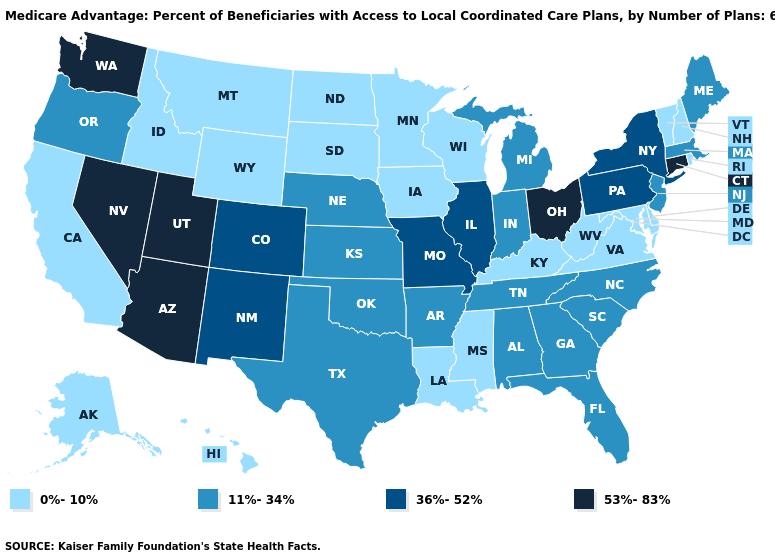Does New Jersey have a lower value than Arizona?
Concise answer only. Yes. What is the value of Texas?
Short answer required. 11%-34%. Does Massachusetts have a higher value than Maine?
Quick response, please. No. Among the states that border Illinois , does Wisconsin have the highest value?
Write a very short answer. No. Which states have the highest value in the USA?
Short answer required. Arizona, Connecticut, Nevada, Ohio, Utah, Washington. Among the states that border Oregon , does Idaho have the lowest value?
Write a very short answer. Yes. Does Georgia have the lowest value in the USA?
Keep it brief. No. Name the states that have a value in the range 36%-52%?
Concise answer only. Colorado, Illinois, Missouri, New Mexico, New York, Pennsylvania. Name the states that have a value in the range 11%-34%?
Quick response, please. Alabama, Arkansas, Florida, Georgia, Indiana, Kansas, Massachusetts, Maine, Michigan, North Carolina, Nebraska, New Jersey, Oklahoma, Oregon, South Carolina, Tennessee, Texas. Does the map have missing data?
Be succinct. No. Which states have the highest value in the USA?
Short answer required. Arizona, Connecticut, Nevada, Ohio, Utah, Washington. Is the legend a continuous bar?
Concise answer only. No. Which states have the lowest value in the Northeast?
Give a very brief answer. New Hampshire, Rhode Island, Vermont. Which states have the lowest value in the Northeast?
Answer briefly. New Hampshire, Rhode Island, Vermont. Name the states that have a value in the range 36%-52%?
Quick response, please. Colorado, Illinois, Missouri, New Mexico, New York, Pennsylvania. 